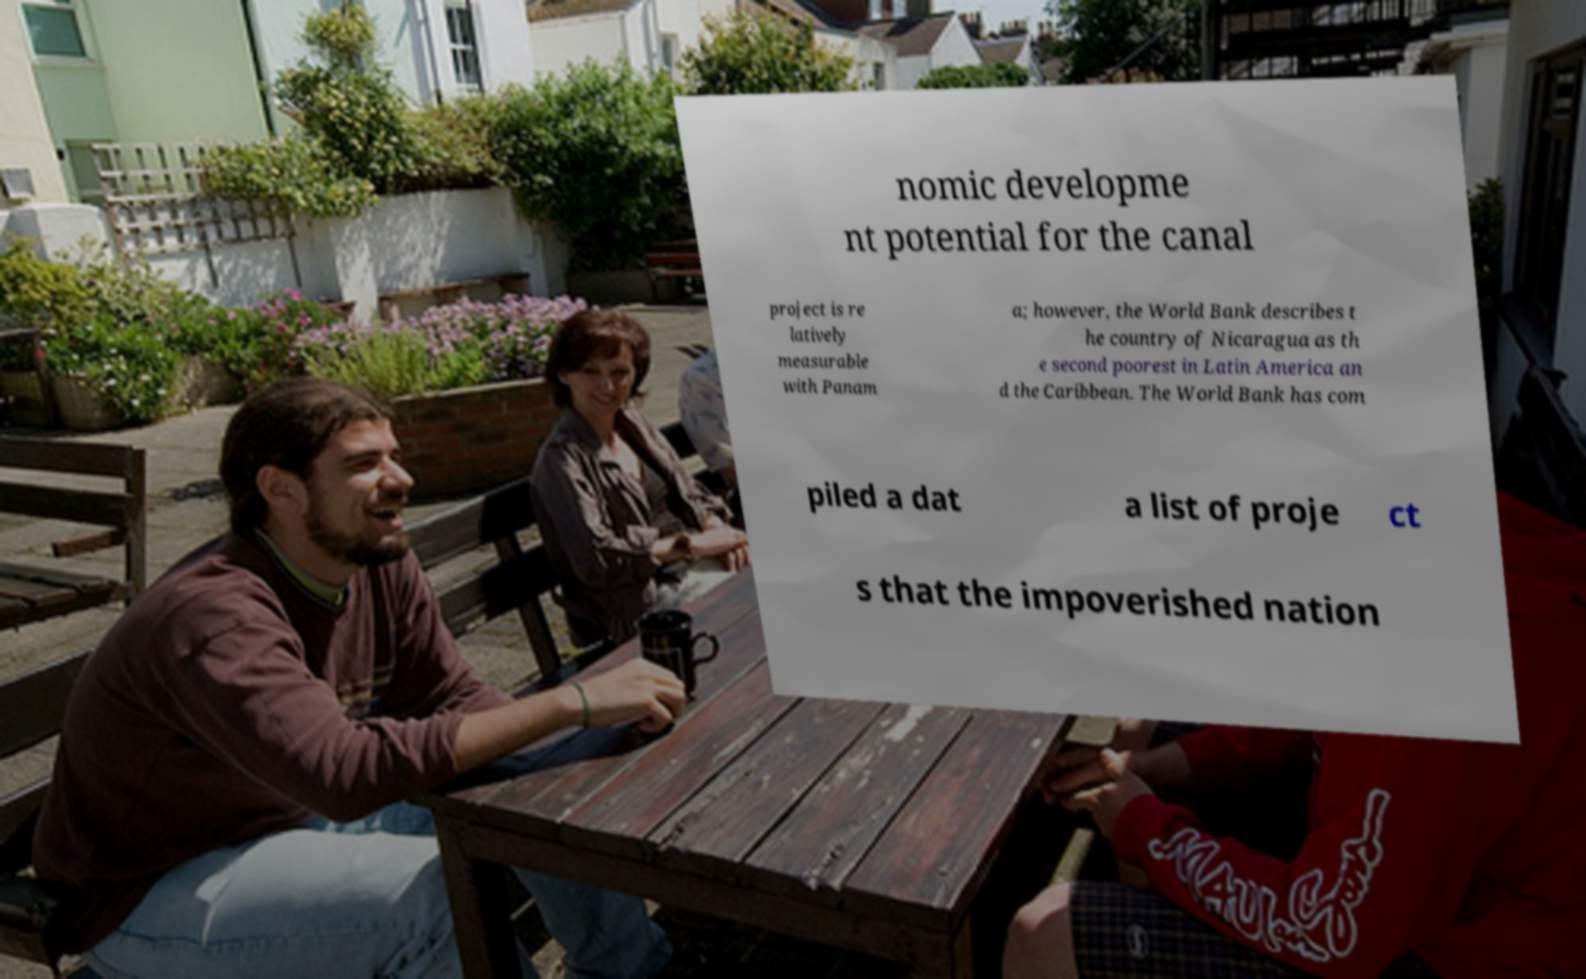There's text embedded in this image that I need extracted. Can you transcribe it verbatim? nomic developme nt potential for the canal project is re latively measurable with Panam a; however, the World Bank describes t he country of Nicaragua as th e second poorest in Latin America an d the Caribbean. The World Bank has com piled a dat a list of proje ct s that the impoverished nation 